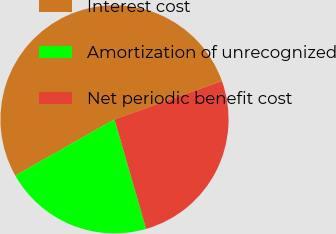Convert chart to OTSL. <chart><loc_0><loc_0><loc_500><loc_500><pie_chart><fcel>Interest cost<fcel>Amortization of unrecognized<fcel>Net periodic benefit cost<nl><fcel>52.76%<fcel>21.26%<fcel>25.98%<nl></chart> 